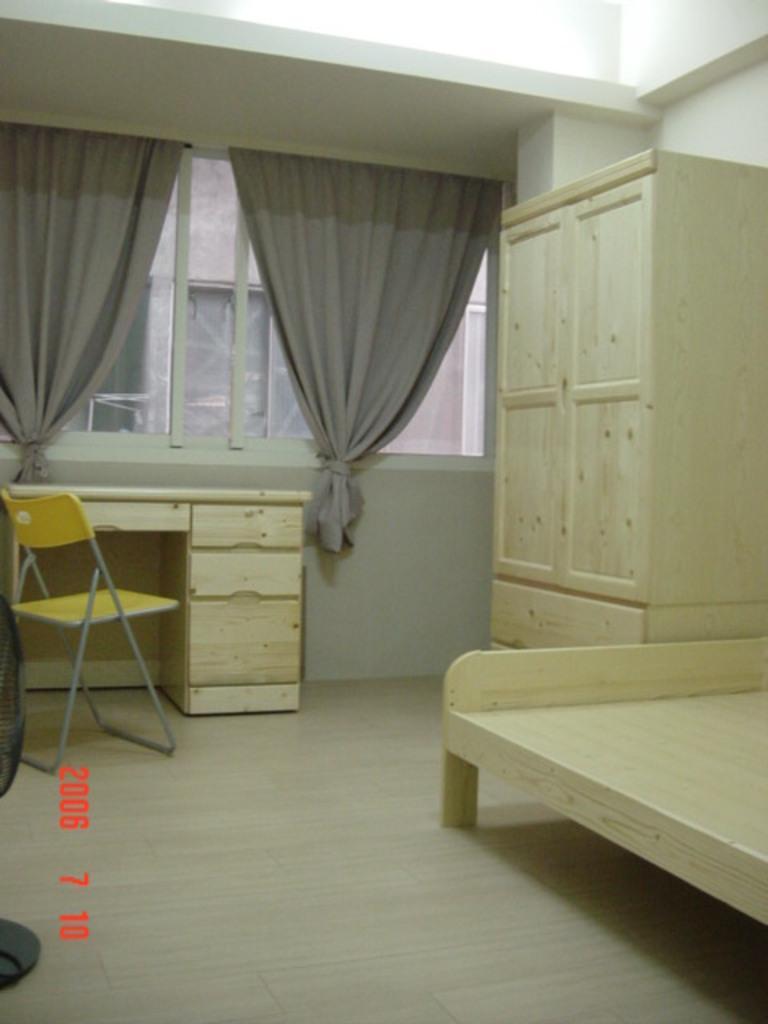Could you give a brief overview of what you see in this image? In this image on the right side there is a wooden cot and there is a wooden cup board and there is a window ,on the window there is a curtain. on back side of window there is a building. In Front of the window there is a table. And near to the table there is chair on the floor and left side some text written on the image. 